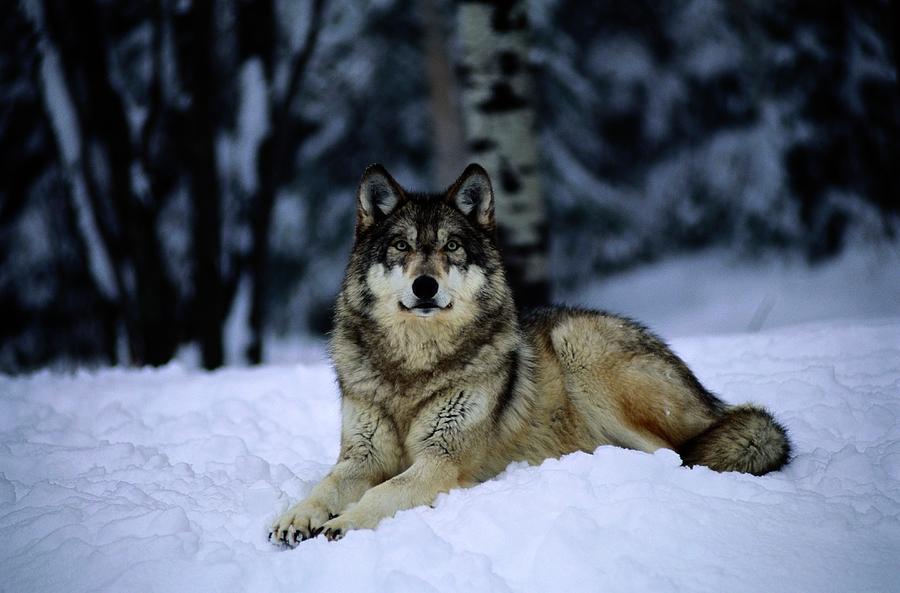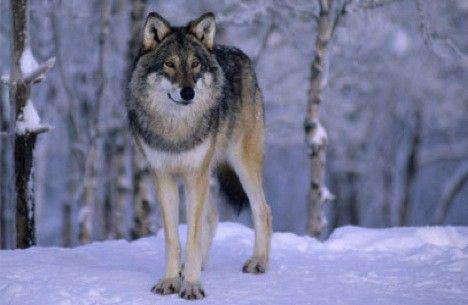The first image is the image on the left, the second image is the image on the right. Assess this claim about the two images: "There is a wolf sitting in the snow". Correct or not? Answer yes or no. Yes. 